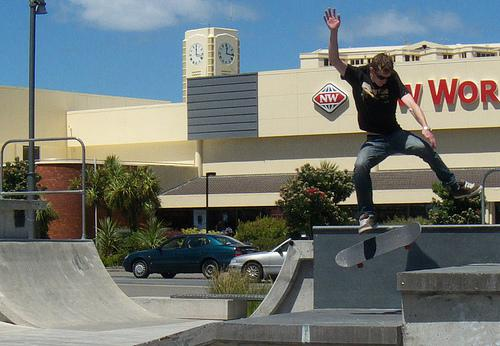Question: what is the young man doing?
Choices:
A. Surfing.
B. Biking.
C. Skateboarding.
D. Skiing.
Answer with the letter. Answer: C Question: where is the young man?
Choices:
A. In the air.
B. On the bed.
C. Behind the sofa.
D. In the car.
Answer with the letter. Answer: A Question: where is this scene?
Choices:
A. A skate park.
B. At the beach.
C. In the car.
D. At the circus.
Answer with the letter. Answer: A Question: where are the clocks?
Choices:
A. In a shop.
B. At the zoo.
C. In a museum.
D. On top of the building.
Answer with the letter. Answer: D Question: when is this?
Choices:
A. At night.
B. Before sunrise.
C. During the day.
D. In the fall.
Answer with the letter. Answer: C Question: how many cars are there?
Choices:
A. Three.
B. One.
C. Two.
D. None.
Answer with the letter. Answer: C 